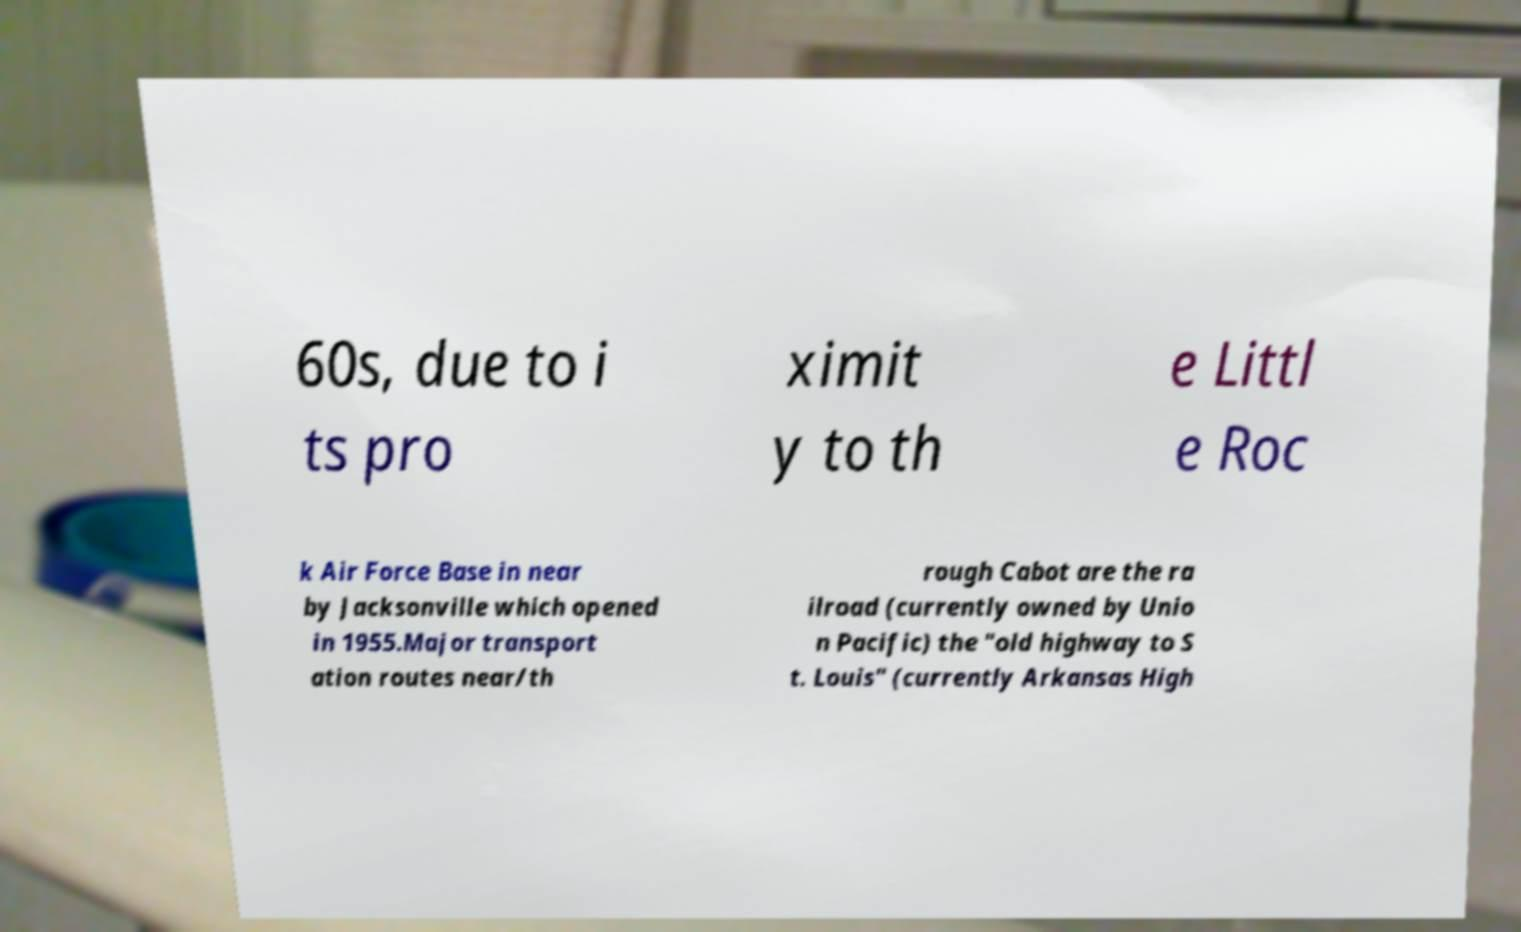Can you read and provide the text displayed in the image?This photo seems to have some interesting text. Can you extract and type it out for me? 60s, due to i ts pro ximit y to th e Littl e Roc k Air Force Base in near by Jacksonville which opened in 1955.Major transport ation routes near/th rough Cabot are the ra ilroad (currently owned by Unio n Pacific) the "old highway to S t. Louis" (currently Arkansas High 